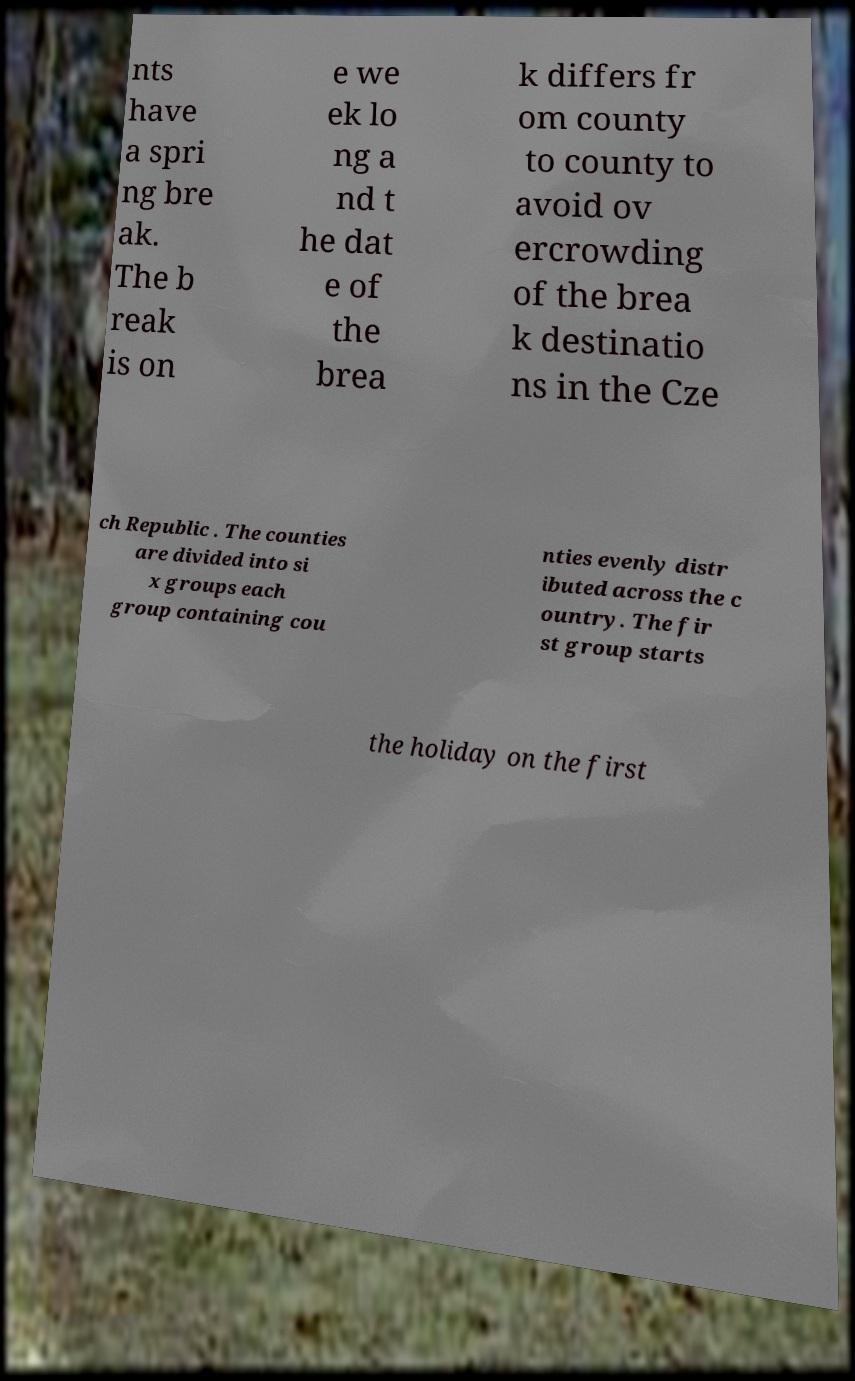Could you assist in decoding the text presented in this image and type it out clearly? nts have a spri ng bre ak. The b reak is on e we ek lo ng a nd t he dat e of the brea k differs fr om county to county to avoid ov ercrowding of the brea k destinatio ns in the Cze ch Republic . The counties are divided into si x groups each group containing cou nties evenly distr ibuted across the c ountry. The fir st group starts the holiday on the first 